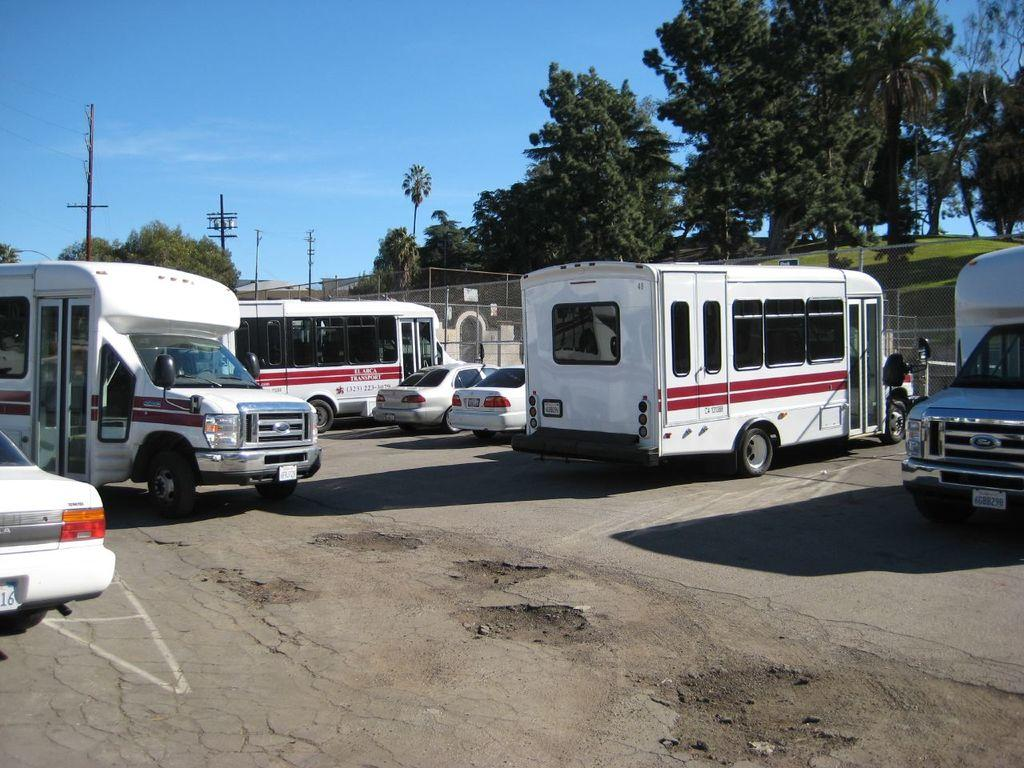What can be seen in the image that moves or transports people or goods? There are vehicles in the image that move or transport people or goods. What structures can be seen in the background of the image? There are electric poles in the background of the image. What type of vegetation is present in the image? There are trees with green color in the image. What color is the sky in the image? The sky is blue in the image. What type of flower is growing near the electric poles in the image? There are no flowers visible in the image; it only shows vehicles, electric poles, trees, and the sky. 